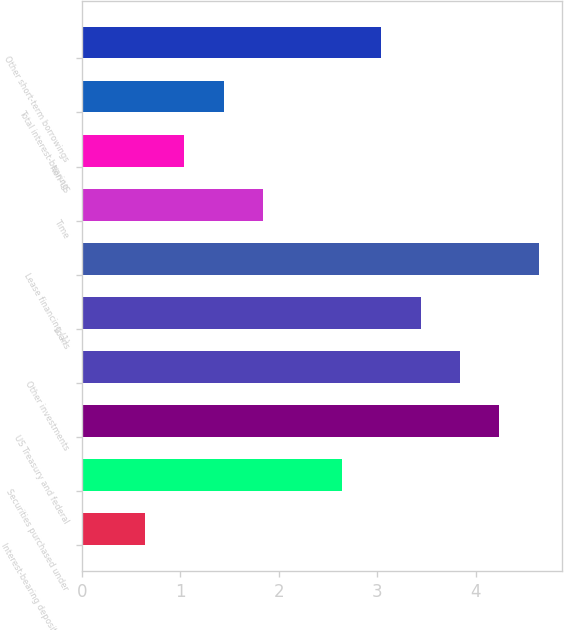<chart> <loc_0><loc_0><loc_500><loc_500><bar_chart><fcel>Interest-bearing deposits with<fcel>Securities purchased under<fcel>US Treasury and federal<fcel>Other investments<fcel>Loans<fcel>Lease financing (1)<fcel>Time<fcel>Non-US<fcel>Total interest-bearing<fcel>Other short-term borrowings<nl><fcel>0.64<fcel>2.64<fcel>4.24<fcel>3.84<fcel>3.44<fcel>4.64<fcel>1.84<fcel>1.04<fcel>1.44<fcel>3.04<nl></chart> 